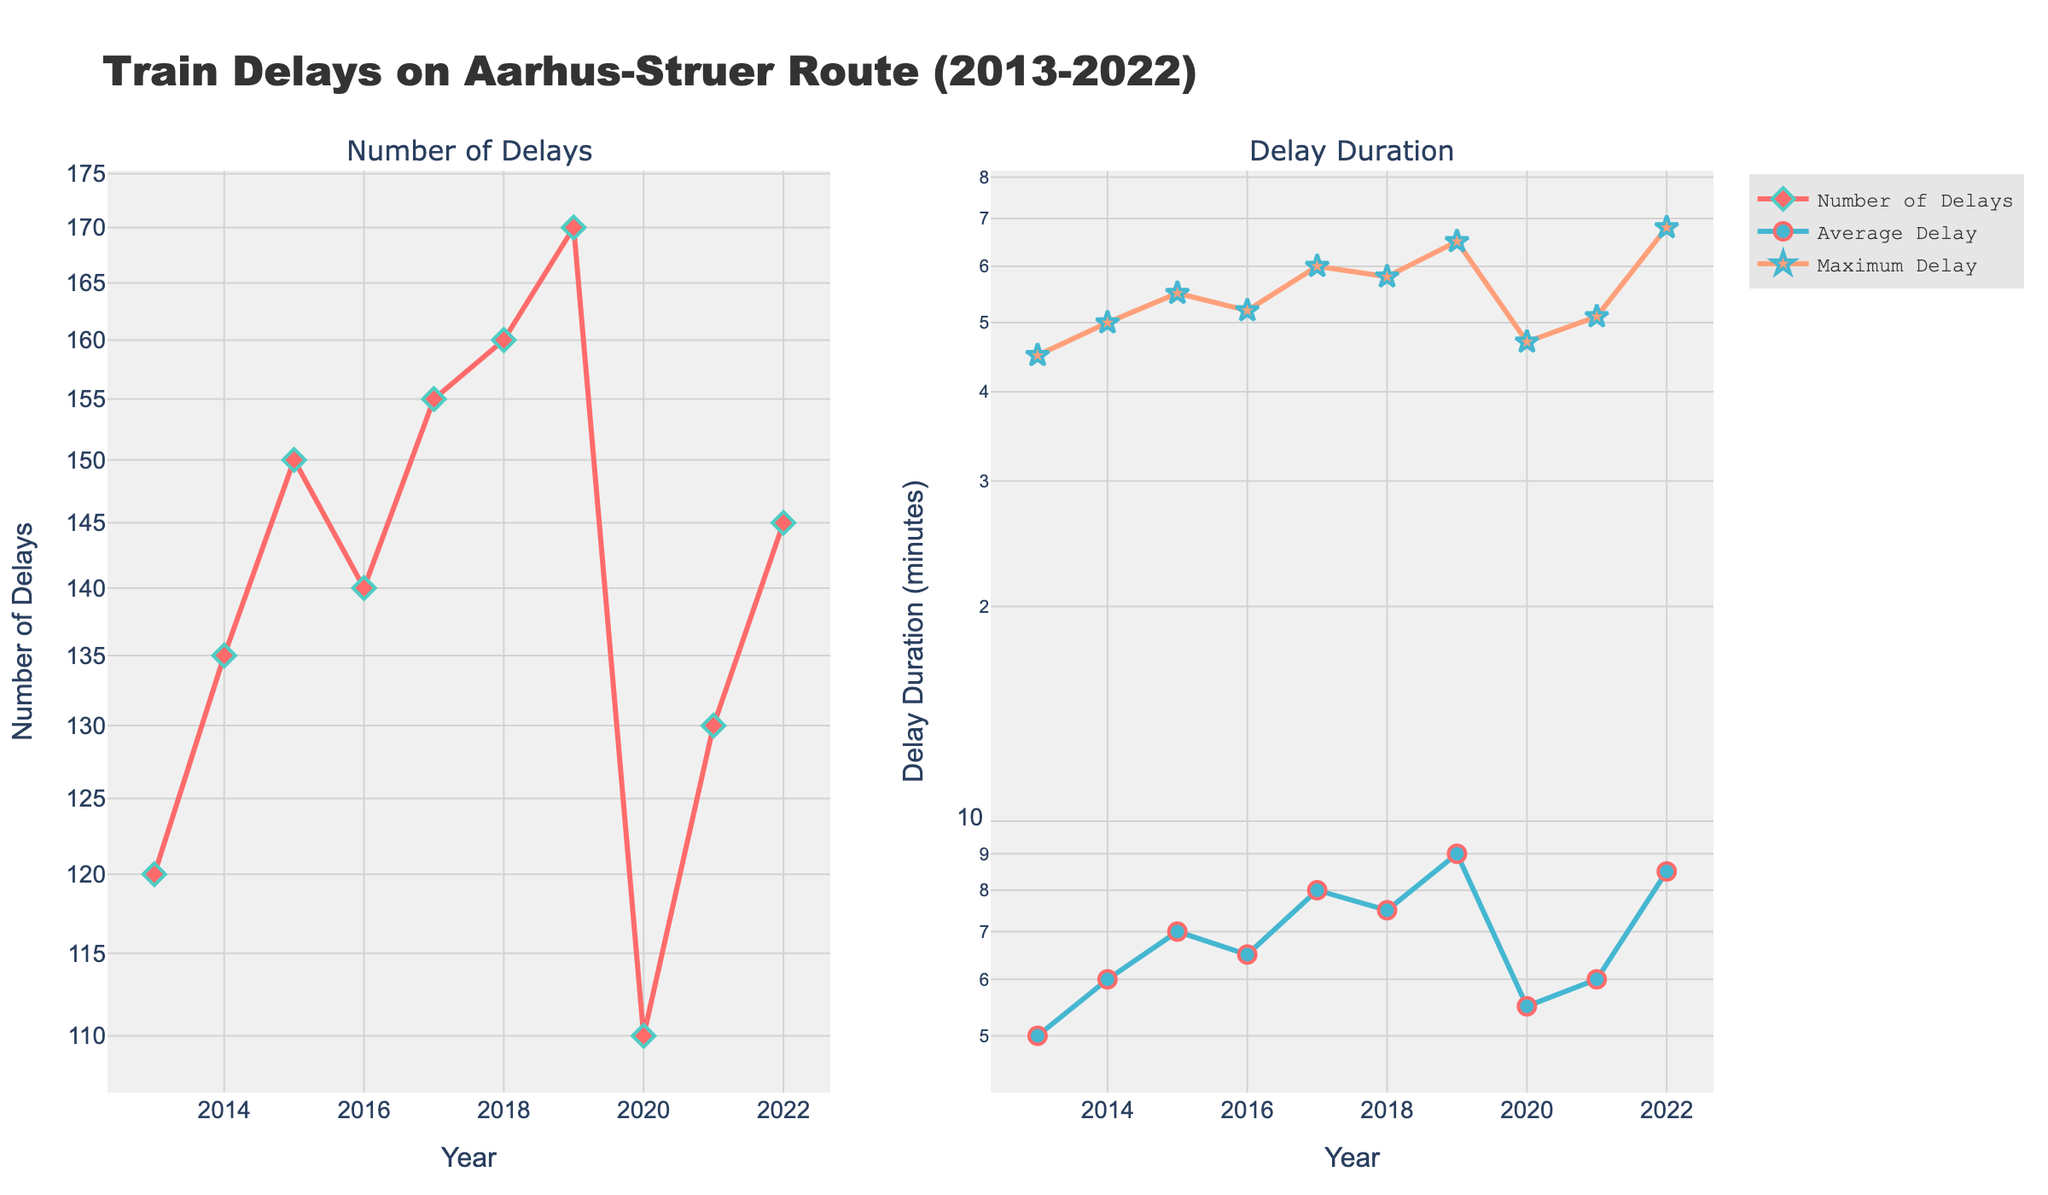Can you describe the layout of the figure? The figure is divided into two subplots side by side, one for the "Number of Delays" and the other for "Delay Duration". The title is "Train Delays on Aarhus-Struer Route (2013-2022)".
Answer: Two subplots side by side What's the trend in the number of delays over the decade? The trend shows an overall increase in the number of delays from 2013 to 2019, then a drop in 2020, followed by a slight increase again up to 2022.
Answer: Increasing then slight drop and increase again Which year shows the maximum average delay? Looking at the right subplot showing delay duration, the year with the highest point in the average delay line is 2022.
Answer: 2022 How do the average delay and maximum delay compare in 2017? In 2017, the average delay is significantly lower than the maximum delay, with the average being 8 minutes and the maximum being 60 minutes.
Answer: Average: 8 min, Maximum: 60 min What is the difference in the number of delays between 2019 and 2020? The number of delays in 2019 is 170 and in 2020 it is 110. The difference is 170 - 110 = 60.
Answer: 60 Did the maximum delay ever exceed 65 minutes? Yes, the maximum delay exceeded 65 minutes in 2022, where it reached 68 minutes.
Answer: Yes What is the trend of maximum delays over time? The maximum delay generally follows an increasing trend from 2013 to 2019, drops in 2020, and then increases again, peaking in 2022.
Answer: Increasing trend with dips In which year was the smallest number of delays recorded? The subplot showing "Number of Delays" indicates the smallest number of delays was in 2020, with 110 delays.
Answer: 2020 What was the maximum delay in 2015, and how does it compare to the average delay that year? In 2015, the maximum delay was 55 minutes, while the average delay was 7 minutes. The maximum delay was almost eight times the average delay.
Answer: Max: 55 min, Avg: 7 min How significant was the decrease in the number of delays from 2019 to 2020? The decrease was quite significant, as the number of delays dropped from 170 in 2019 to 110 in 2020, a decrease of about 35%.
Answer: Significant, ~35% 